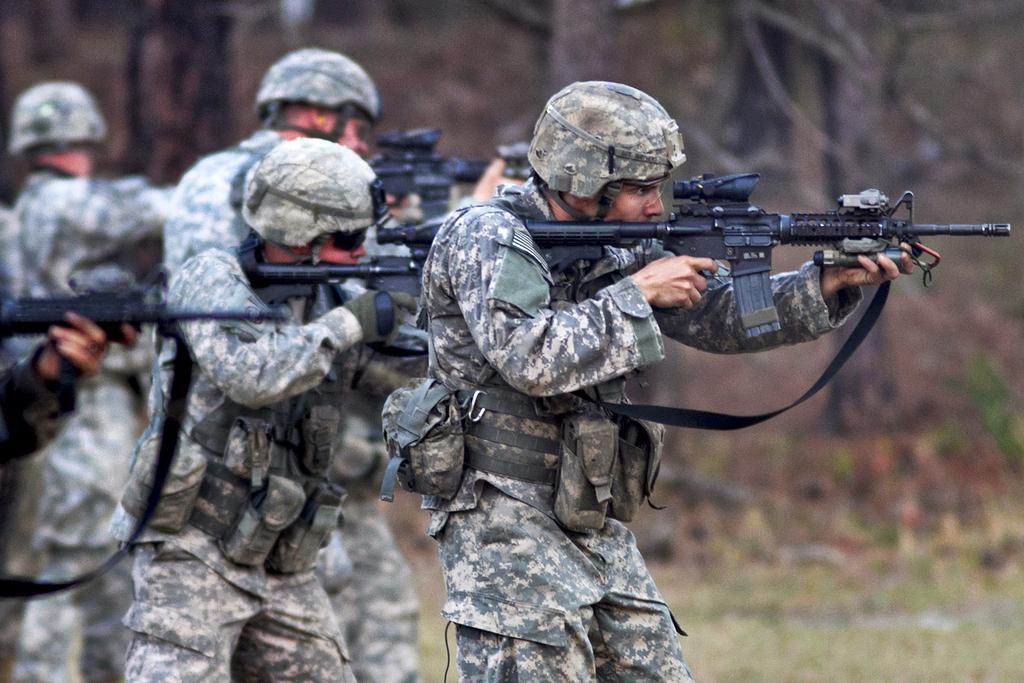Could you give a brief overview of what you see in this image? In this picture we can see a few people holding guns in their hands. Background is blurry. 